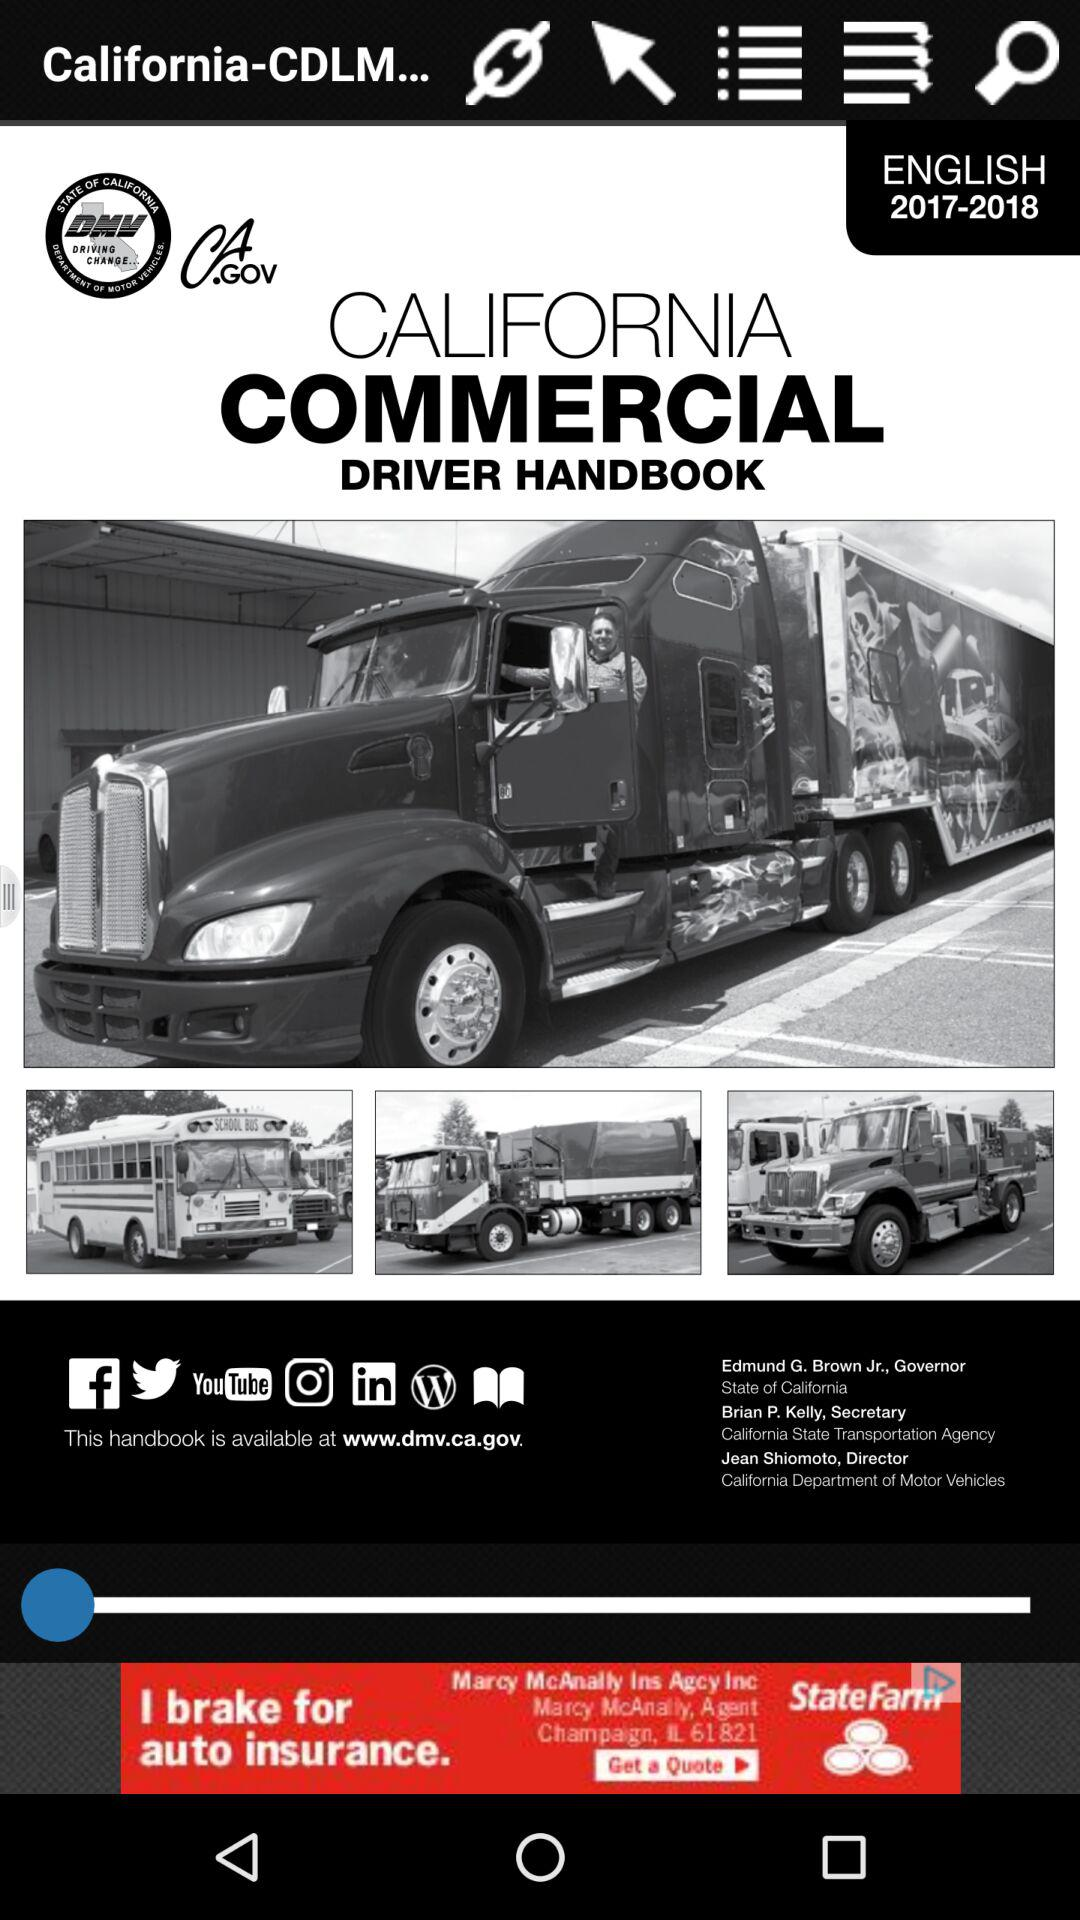What is the time period?
When the provided information is insufficient, respond with <no answer>. <no answer> 